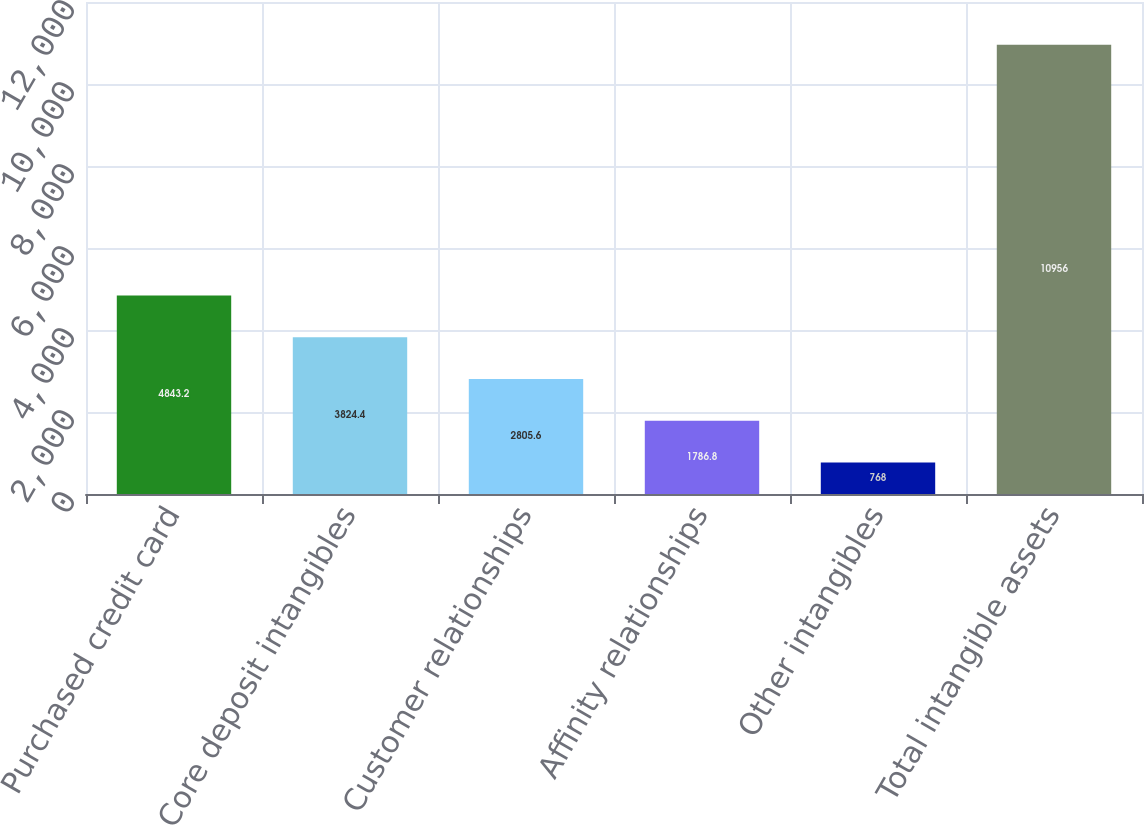Convert chart. <chart><loc_0><loc_0><loc_500><loc_500><bar_chart><fcel>Purchased credit card<fcel>Core deposit intangibles<fcel>Customer relationships<fcel>Affinity relationships<fcel>Other intangibles<fcel>Total intangible assets<nl><fcel>4843.2<fcel>3824.4<fcel>2805.6<fcel>1786.8<fcel>768<fcel>10956<nl></chart> 